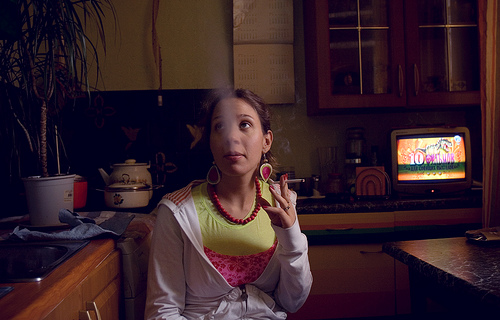<image>What are the displays celebrating? I'm not sure what the displays are celebrating. It could be a birthday, a 10 year anniversary, summer, or life. What game system is this woman using? It is unknown what game system the woman is using. It could possibly be a Nintendo Wii or Android. What game system is this woman using? It is not clear what game system the woman is using. It can be seen 'nintendo wii' or 'wii'. What are the displays celebrating? I am not sure what the displays are celebrating. It can be seen 'birthday', 'summer', 'anniversary', or '10 year anniversary'. 